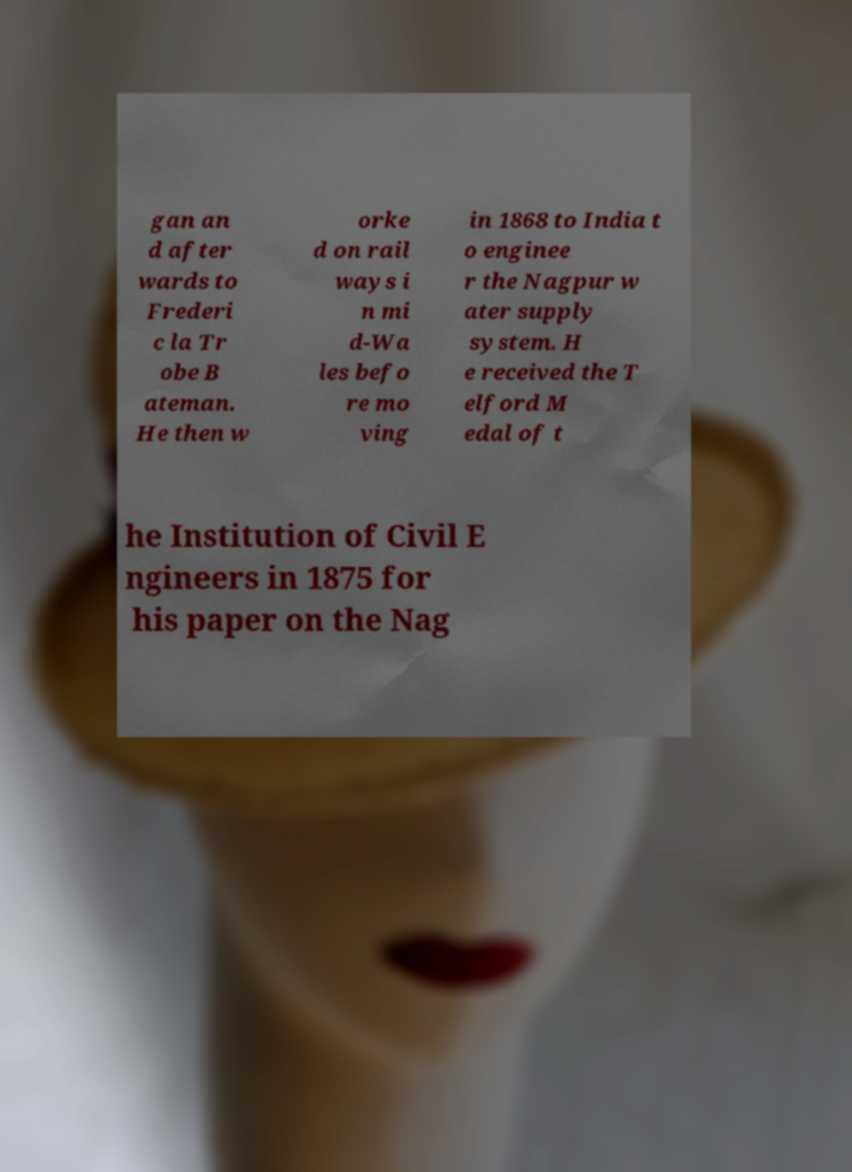Can you accurately transcribe the text from the provided image for me? gan an d after wards to Frederi c la Tr obe B ateman. He then w orke d on rail ways i n mi d-Wa les befo re mo ving in 1868 to India t o enginee r the Nagpur w ater supply system. H e received the T elford M edal of t he Institution of Civil E ngineers in 1875 for his paper on the Nag 